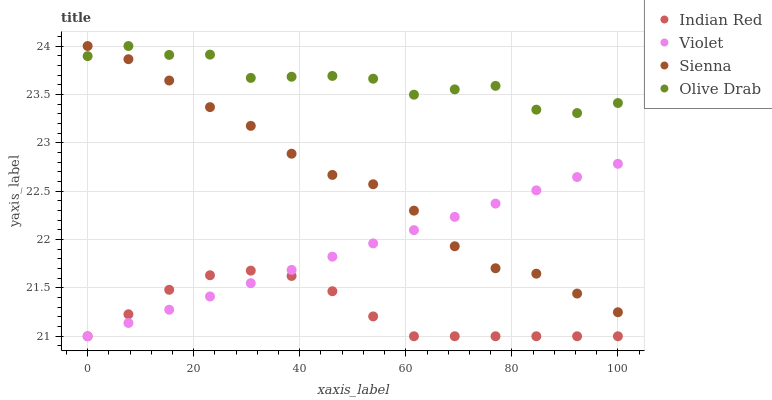Does Indian Red have the minimum area under the curve?
Answer yes or no. Yes. Does Olive Drab have the maximum area under the curve?
Answer yes or no. Yes. Does Olive Drab have the minimum area under the curve?
Answer yes or no. No. Does Indian Red have the maximum area under the curve?
Answer yes or no. No. Is Violet the smoothest?
Answer yes or no. Yes. Is Olive Drab the roughest?
Answer yes or no. Yes. Is Indian Red the smoothest?
Answer yes or no. No. Is Indian Red the roughest?
Answer yes or no. No. Does Indian Red have the lowest value?
Answer yes or no. Yes. Does Olive Drab have the lowest value?
Answer yes or no. No. Does Olive Drab have the highest value?
Answer yes or no. Yes. Does Indian Red have the highest value?
Answer yes or no. No. Is Indian Red less than Olive Drab?
Answer yes or no. Yes. Is Olive Drab greater than Indian Red?
Answer yes or no. Yes. Does Violet intersect Indian Red?
Answer yes or no. Yes. Is Violet less than Indian Red?
Answer yes or no. No. Is Violet greater than Indian Red?
Answer yes or no. No. Does Indian Red intersect Olive Drab?
Answer yes or no. No. 